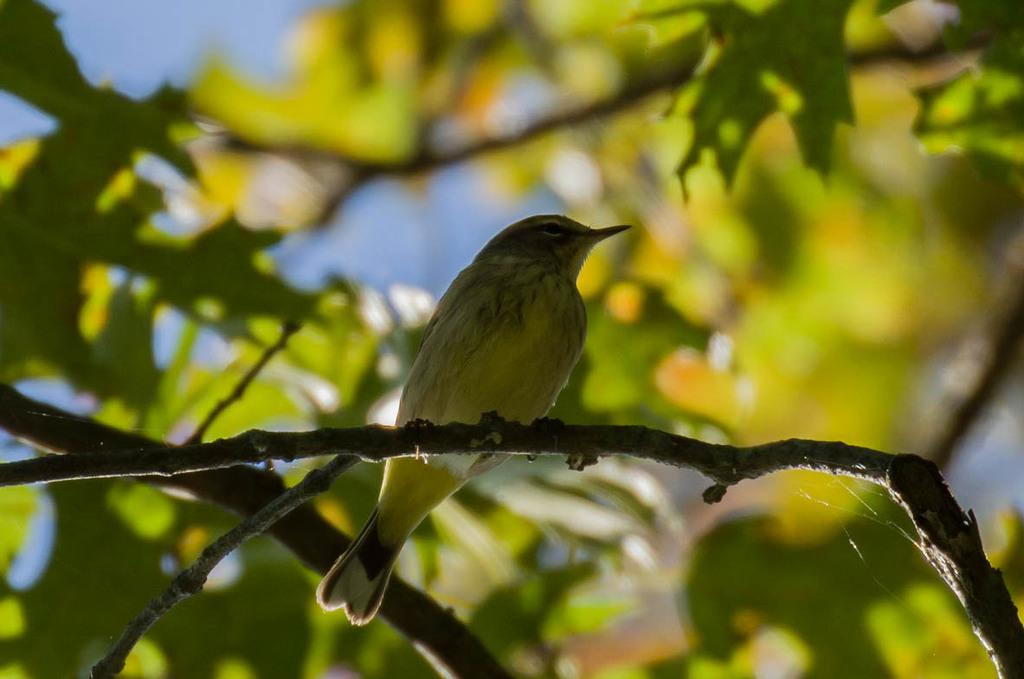What type of animal is in the image? There is a bird in the image. Where is the bird located? The bird is standing on a branch of a tree. What can be seen in the background of the image? There are leaves visible in the background of the image. What color is the crayon that the bird is holding in the image? There is no crayon present in the image; the bird is standing on a branch of a tree. 